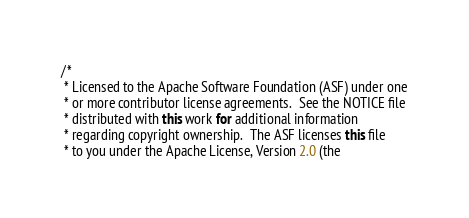Convert code to text. <code><loc_0><loc_0><loc_500><loc_500><_Java_>/*
 * Licensed to the Apache Software Foundation (ASF) under one
 * or more contributor license agreements.  See the NOTICE file
 * distributed with this work for additional information
 * regarding copyright ownership.  The ASF licenses this file
 * to you under the Apache License, Version 2.0 (the</code> 